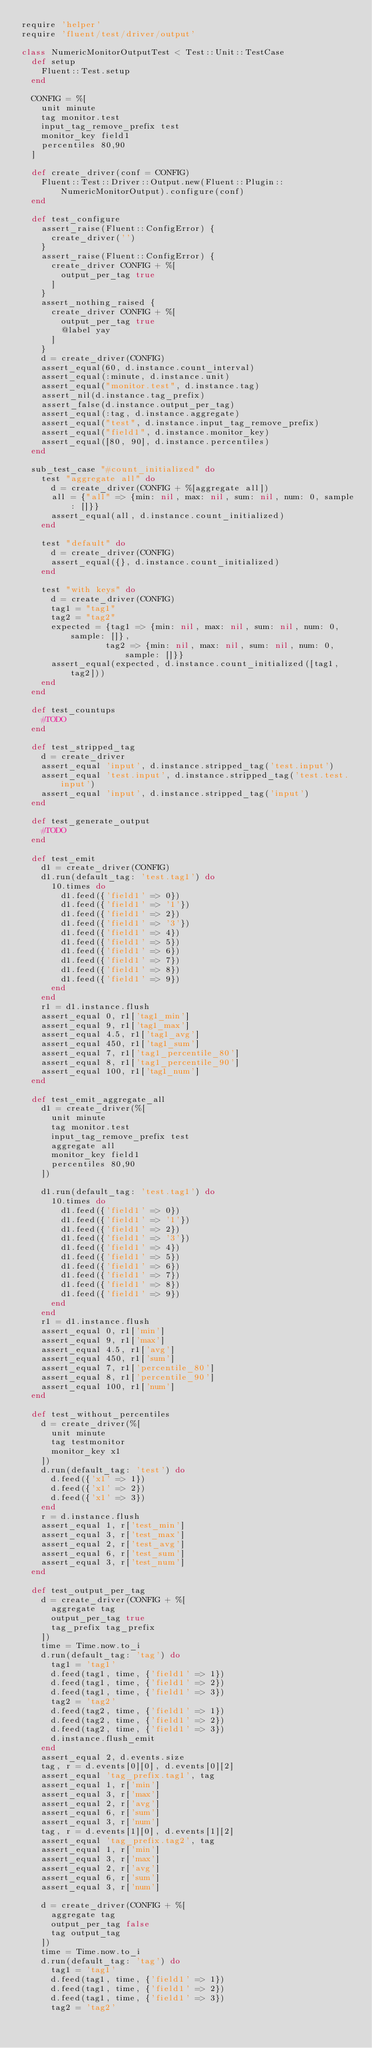Convert code to text. <code><loc_0><loc_0><loc_500><loc_500><_Ruby_>require 'helper'
require 'fluent/test/driver/output'

class NumericMonitorOutputTest < Test::Unit::TestCase
  def setup
    Fluent::Test.setup
  end

  CONFIG = %[
    unit minute
    tag monitor.test
    input_tag_remove_prefix test
    monitor_key field1
    percentiles 80,90
  ]

  def create_driver(conf = CONFIG)
    Fluent::Test::Driver::Output.new(Fluent::Plugin::NumericMonitorOutput).configure(conf)
  end

  def test_configure
    assert_raise(Fluent::ConfigError) {
      create_driver('')
    }
    assert_raise(Fluent::ConfigError) {
      create_driver CONFIG + %[
        output_per_tag true
      ]
    }
    assert_nothing_raised {
      create_driver CONFIG + %[
        output_per_tag true
        @label yay
      ]
    }
    d = create_driver(CONFIG)
    assert_equal(60, d.instance.count_interval)
    assert_equal(:minute, d.instance.unit)
    assert_equal("monitor.test", d.instance.tag)
    assert_nil(d.instance.tag_prefix)
    assert_false(d.instance.output_per_tag)
    assert_equal(:tag, d.instance.aggregate)
    assert_equal("test", d.instance.input_tag_remove_prefix)
    assert_equal("field1", d.instance.monitor_key)
    assert_equal([80, 90], d.instance.percentiles)
  end

  sub_test_case "#count_initialized" do
    test "aggregate all" do
      d = create_driver(CONFIG + %[aggregate all])
      all = {"all" => {min: nil, max: nil, sum: nil, num: 0, sample: []}}
      assert_equal(all, d.instance.count_initialized)
    end

    test "default" do
      d = create_driver(CONFIG)
      assert_equal({}, d.instance.count_initialized)
    end

    test "with keys" do
      d = create_driver(CONFIG)
      tag1 = "tag1"
      tag2 = "tag2"
      expected = {tag1 => {min: nil, max: nil, sum: nil, num: 0, sample: []},
                 tag2 => {min: nil, max: nil, sum: nil, num: 0, sample: []}}
      assert_equal(expected, d.instance.count_initialized([tag1, tag2]))
    end
  end

  def test_countups
    #TODO
  end

  def test_stripped_tag
    d = create_driver
    assert_equal 'input', d.instance.stripped_tag('test.input')
    assert_equal 'test.input', d.instance.stripped_tag('test.test.input')
    assert_equal 'input', d.instance.stripped_tag('input')
  end

  def test_generate_output
    #TODO
  end

  def test_emit
    d1 = create_driver(CONFIG)
    d1.run(default_tag: 'test.tag1') do
      10.times do
        d1.feed({'field1' => 0})
        d1.feed({'field1' => '1'})
        d1.feed({'field1' => 2})
        d1.feed({'field1' => '3'})
        d1.feed({'field1' => 4})
        d1.feed({'field1' => 5})
        d1.feed({'field1' => 6})
        d1.feed({'field1' => 7})
        d1.feed({'field1' => 8})
        d1.feed({'field1' => 9})
      end
    end
    r1 = d1.instance.flush
    assert_equal 0, r1['tag1_min']
    assert_equal 9, r1['tag1_max']
    assert_equal 4.5, r1['tag1_avg']
    assert_equal 450, r1['tag1_sum']
    assert_equal 7, r1['tag1_percentile_80']
    assert_equal 8, r1['tag1_percentile_90']
    assert_equal 100, r1['tag1_num']
  end

  def test_emit_aggregate_all
    d1 = create_driver(%[
      unit minute
      tag monitor.test
      input_tag_remove_prefix test
      aggregate all
      monitor_key field1
      percentiles 80,90
    ])

    d1.run(default_tag: 'test.tag1') do
      10.times do
        d1.feed({'field1' => 0})
        d1.feed({'field1' => '1'})
        d1.feed({'field1' => 2})
        d1.feed({'field1' => '3'})
        d1.feed({'field1' => 4})
        d1.feed({'field1' => 5})
        d1.feed({'field1' => 6})
        d1.feed({'field1' => 7})
        d1.feed({'field1' => 8})
        d1.feed({'field1' => 9})
      end
    end
    r1 = d1.instance.flush
    assert_equal 0, r1['min']
    assert_equal 9, r1['max']
    assert_equal 4.5, r1['avg']
    assert_equal 450, r1['sum']
    assert_equal 7, r1['percentile_80']
    assert_equal 8, r1['percentile_90']
    assert_equal 100, r1['num']
  end

  def test_without_percentiles
    d = create_driver(%[
      unit minute
      tag testmonitor
      monitor_key x1
    ])
    d.run(default_tag: 'test') do
      d.feed({'x1' => 1})
      d.feed({'x1' => 2})
      d.feed({'x1' => 3})
    end
    r = d.instance.flush
    assert_equal 1, r['test_min']
    assert_equal 3, r['test_max']
    assert_equal 2, r['test_avg']
    assert_equal 6, r['test_sum']
    assert_equal 3, r['test_num']
  end

  def test_output_per_tag
    d = create_driver(CONFIG + %[
      aggregate tag
      output_per_tag true
      tag_prefix tag_prefix
    ])
    time = Time.now.to_i
    d.run(default_tag: 'tag') do
      tag1 = 'tag1'
      d.feed(tag1, time, {'field1' => 1})
      d.feed(tag1, time, {'field1' => 2})
      d.feed(tag1, time, {'field1' => 3})
      tag2 = 'tag2'
      d.feed(tag2, time, {'field1' => 1})
      d.feed(tag2, time, {'field1' => 2})
      d.feed(tag2, time, {'field1' => 3})
      d.instance.flush_emit
    end
    assert_equal 2, d.events.size
    tag, r = d.events[0][0], d.events[0][2]
    assert_equal 'tag_prefix.tag1', tag
    assert_equal 1, r['min']
    assert_equal 3, r['max']
    assert_equal 2, r['avg']
    assert_equal 6, r['sum']
    assert_equal 3, r['num']
    tag, r = d.events[1][0], d.events[1][2]
    assert_equal 'tag_prefix.tag2', tag
    assert_equal 1, r['min']
    assert_equal 3, r['max']
    assert_equal 2, r['avg']
    assert_equal 6, r['sum']
    assert_equal 3, r['num']

    d = create_driver(CONFIG + %[
      aggregate tag
      output_per_tag false
      tag output_tag
    ])
    time = Time.now.to_i
    d.run(default_tag: 'tag') do
      tag1 = 'tag1'
      d.feed(tag1, time, {'field1' => 1})
      d.feed(tag1, time, {'field1' => 2})
      d.feed(tag1, time, {'field1' => 3})
      tag2 = 'tag2'</code> 